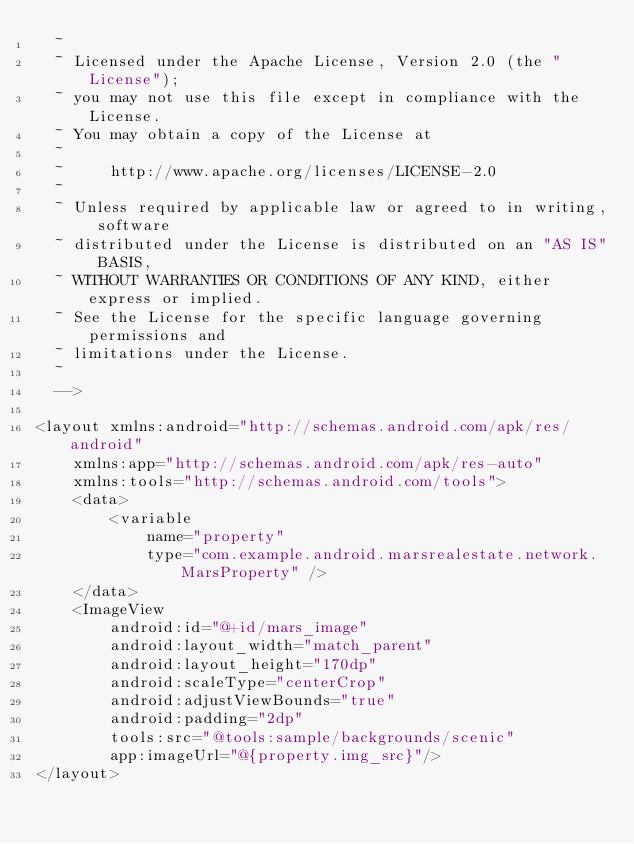<code> <loc_0><loc_0><loc_500><loc_500><_XML_>  ~
  ~ Licensed under the Apache License, Version 2.0 (the "License");
  ~ you may not use this file except in compliance with the License.
  ~ You may obtain a copy of the License at
  ~
  ~     http://www.apache.org/licenses/LICENSE-2.0
  ~
  ~ Unless required by applicable law or agreed to in writing, software
  ~ distributed under the License is distributed on an "AS IS" BASIS,
  ~ WITHOUT WARRANTIES OR CONDITIONS OF ANY KIND, either express or implied.
  ~ See the License for the specific language governing permissions and
  ~ limitations under the License.
  ~
  -->

<layout xmlns:android="http://schemas.android.com/apk/res/android"
    xmlns:app="http://schemas.android.com/apk/res-auto"
    xmlns:tools="http://schemas.android.com/tools">
    <data>
        <variable
            name="property"
            type="com.example.android.marsrealestate.network.MarsProperty" />
    </data>
    <ImageView
        android:id="@+id/mars_image"
        android:layout_width="match_parent"
        android:layout_height="170dp"
        android:scaleType="centerCrop"
        android:adjustViewBounds="true"
        android:padding="2dp"
        tools:src="@tools:sample/backgrounds/scenic"
        app:imageUrl="@{property.img_src}"/>
</layout>
</code> 